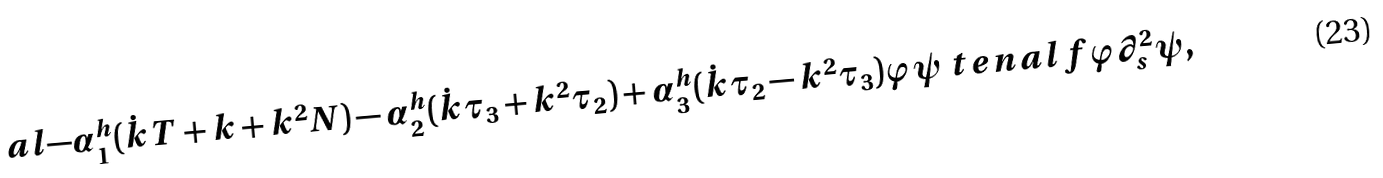Convert formula to latex. <formula><loc_0><loc_0><loc_500><loc_500>a l { - \alpha ^ { h } _ { 1 } ( \dot { k } T + k + k ^ { 2 } N ) - \alpha ^ { h } _ { 2 } ( \dot { k } \tau _ { 3 } + k ^ { 2 } \tau _ { 2 } ) + \alpha ^ { h } _ { 3 } ( \dot { k } \tau _ { 2 } - k ^ { 2 } \tau _ { 3 } ) } { \varphi \psi } \ t e n a l { f } { \varphi \partial _ { s } ^ { 2 } \psi } ,</formula> 